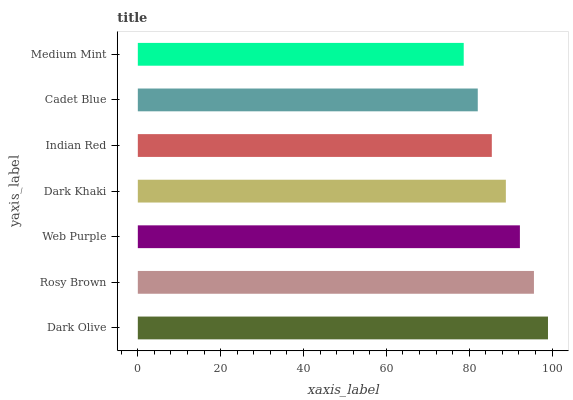Is Medium Mint the minimum?
Answer yes or no. Yes. Is Dark Olive the maximum?
Answer yes or no. Yes. Is Rosy Brown the minimum?
Answer yes or no. No. Is Rosy Brown the maximum?
Answer yes or no. No. Is Dark Olive greater than Rosy Brown?
Answer yes or no. Yes. Is Rosy Brown less than Dark Olive?
Answer yes or no. Yes. Is Rosy Brown greater than Dark Olive?
Answer yes or no. No. Is Dark Olive less than Rosy Brown?
Answer yes or no. No. Is Dark Khaki the high median?
Answer yes or no. Yes. Is Dark Khaki the low median?
Answer yes or no. Yes. Is Cadet Blue the high median?
Answer yes or no. No. Is Cadet Blue the low median?
Answer yes or no. No. 